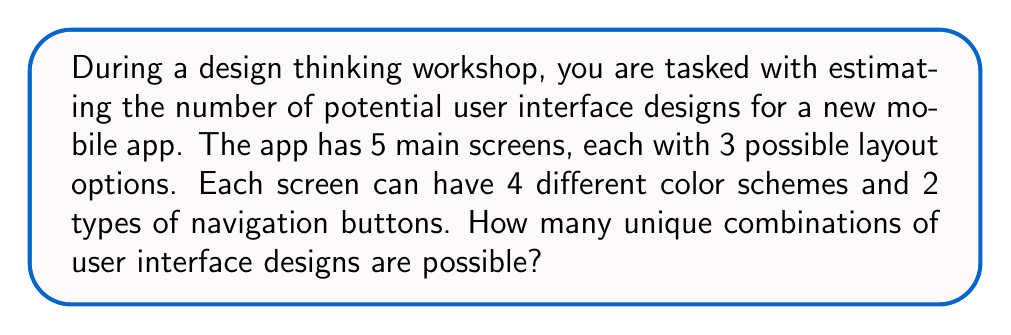What is the answer to this math problem? Let's break this down step-by-step:

1. For each screen, we have:
   - 3 layout options
   - 4 color schemes
   - 2 types of navigation buttons

2. For a single screen, the number of possible combinations is:
   $3 \times 4 \times 2 = 24$

3. We have 5 main screens, and each screen can have its own unique combination.

4. To calculate the total number of possible combinations for all 5 screens, we use the multiplication principle of counting. We multiply the number of possibilities for each screen:

   $24 \times 24 \times 24 \times 24 \times 24 = 24^5$

5. Calculate $24^5$:
   $24^5 = 7,962,624$

Therefore, there are 7,962,624 possible unique combinations of user interface designs for the mobile app.
Answer: $7,962,624$ 